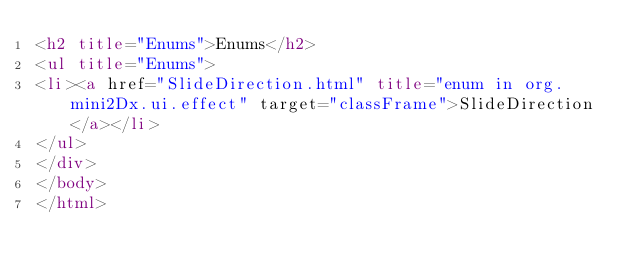Convert code to text. <code><loc_0><loc_0><loc_500><loc_500><_HTML_><h2 title="Enums">Enums</h2>
<ul title="Enums">
<li><a href="SlideDirection.html" title="enum in org.mini2Dx.ui.effect" target="classFrame">SlideDirection</a></li>
</ul>
</div>
</body>
</html>
</code> 